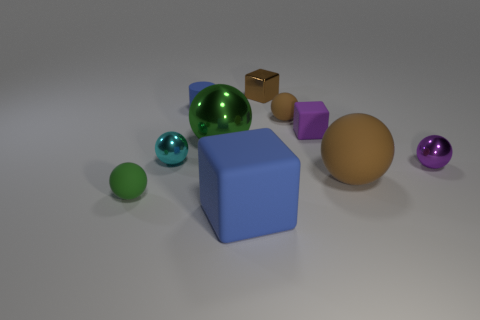Subtract all small cyan metal balls. How many balls are left? 5 Subtract all purple cubes. How many brown balls are left? 2 Subtract 1 blocks. How many blocks are left? 2 Subtract all brown balls. How many balls are left? 4 Subtract all blocks. How many objects are left? 7 Subtract all yellow cubes. Subtract all blue spheres. How many cubes are left? 3 Subtract all blue metal spheres. Subtract all tiny brown metallic objects. How many objects are left? 9 Add 8 purple metal things. How many purple metal things are left? 9 Add 2 tiny brown shiny cubes. How many tiny brown shiny cubes exist? 3 Subtract 0 green blocks. How many objects are left? 10 